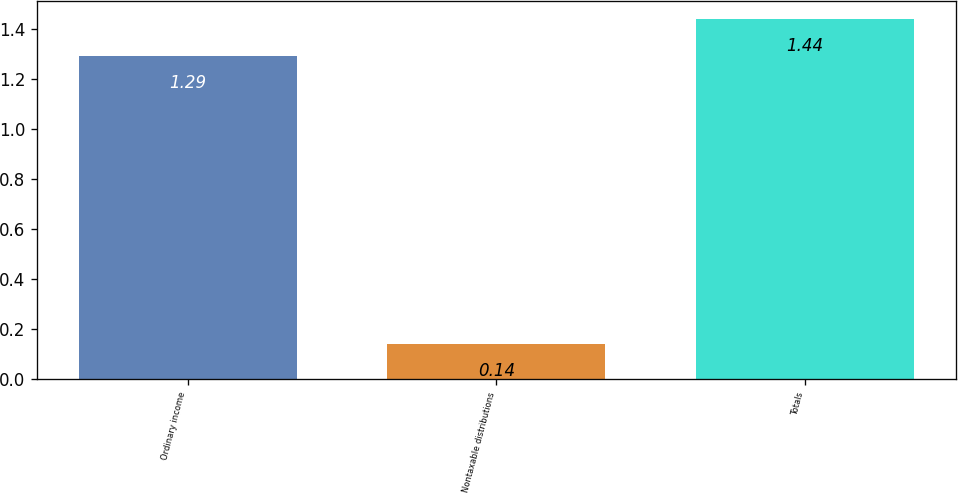Convert chart to OTSL. <chart><loc_0><loc_0><loc_500><loc_500><bar_chart><fcel>Ordinary income<fcel>Nontaxable distributions<fcel>Totals<nl><fcel>1.29<fcel>0.14<fcel>1.44<nl></chart> 